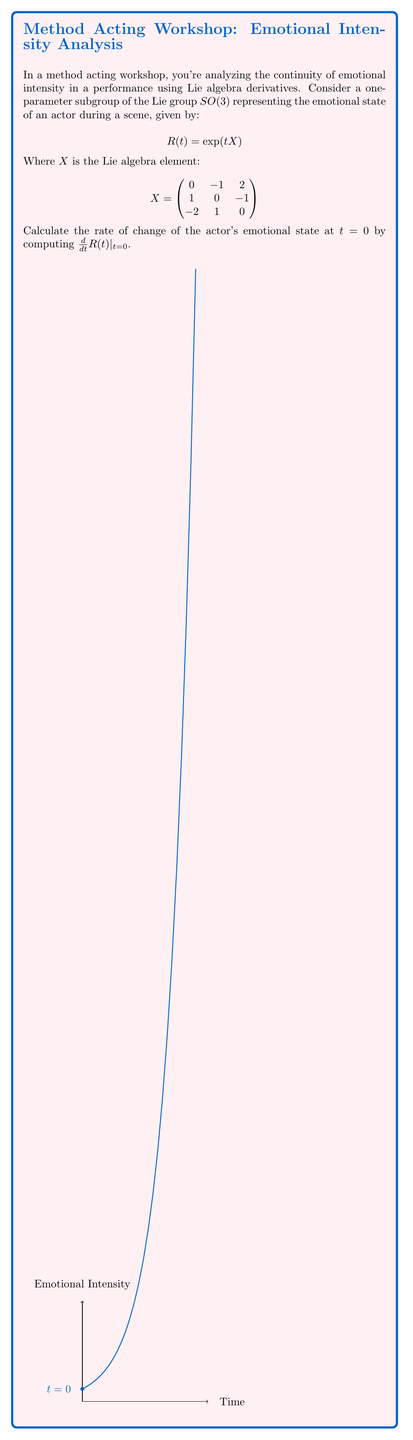Provide a solution to this math problem. To solve this problem, we'll follow these steps:

1) Recall that for a matrix Lie group, the derivative of the exponential map at $t=0$ is given by:

   $$\frac{d}{dt}\exp(tX)|_{t=0} = X$$

2) In our case, $R(t) = \exp(tX)$, so we can directly apply this result:

   $$\frac{d}{dt}R(t)|_{t=0} = X$$

3) Therefore, the rate of change of the actor's emotional state at $t=0$ is simply the Lie algebra element $X$ itself:

   $$\frac{d}{dt}R(t)|_{t=0} = \begin{pmatrix}
   0 & -1 & 2 \\
   1 & 0 & -1 \\
   -2 & 1 & 0
   \end{pmatrix}$$

This matrix represents the instantaneous change in the actor's emotional state at the beginning of the scene $(t=0)$. Each element of the matrix corresponds to the rate of change between different emotional dimensions.
Answer: $$\begin{pmatrix}
0 & -1 & 2 \\
1 & 0 & -1 \\
-2 & 1 & 0
\end{pmatrix}$$ 